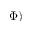<formula> <loc_0><loc_0><loc_500><loc_500>\Phi )</formula> 